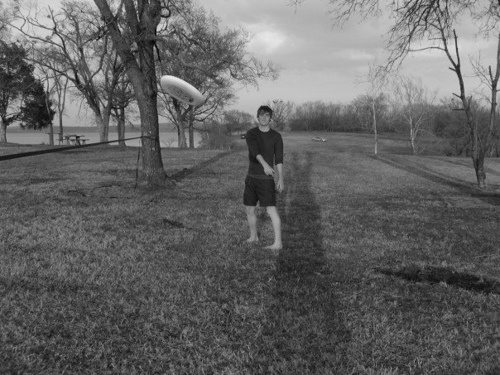Describe the objects in this image and their specific colors. I can see people in gray, black, and lightgray tones, frisbee in lightgray, gray, darkgray, and black tones, dining table in gray, black, and lightgray tones, bench in gray, black, and lightgray tones, and bench in gray, black, and lightgray tones in this image. 